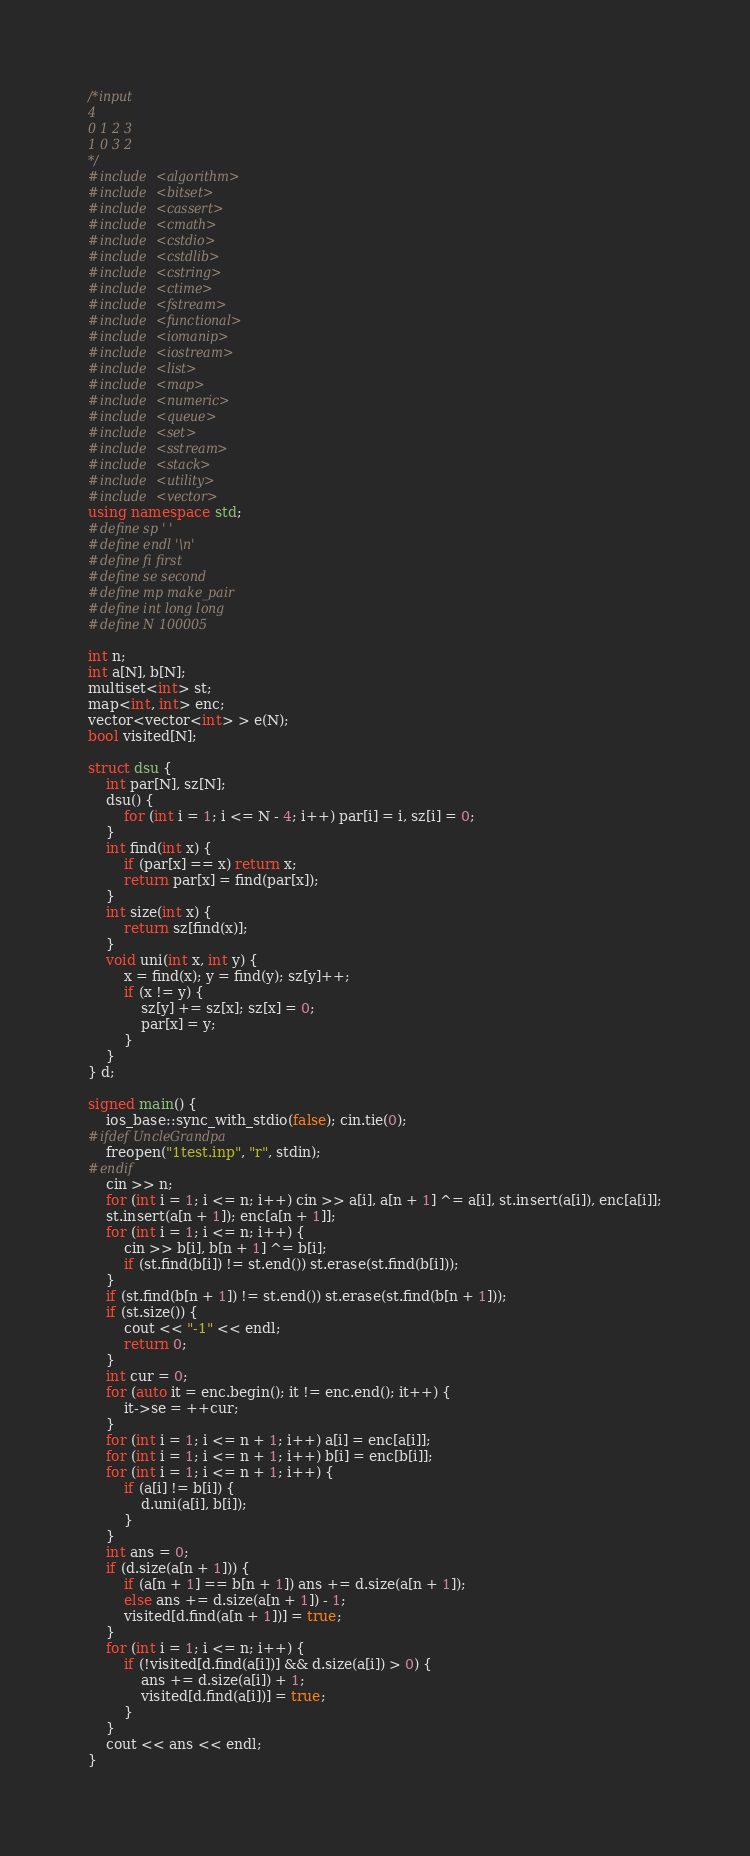<code> <loc_0><loc_0><loc_500><loc_500><_C++_>/*input
4
0 1 2 3
1 0 3 2
*/
#include <algorithm>
#include <bitset>
#include <cassert>
#include <cmath>
#include <cstdio>
#include <cstdlib>
#include <cstring>
#include <ctime>
#include <fstream>
#include <functional>
#include <iomanip>
#include <iostream>
#include <list>
#include <map>
#include <numeric>
#include <queue>
#include <set>
#include <sstream>
#include <stack>
#include <utility>
#include <vector>
using namespace std;
#define sp ' '
#define endl '\n'
#define fi first
#define se second
#define mp make_pair
#define int long long
#define N 100005

int n;
int a[N], b[N];
multiset<int> st;
map<int, int> enc;
vector<vector<int> > e(N);
bool visited[N];

struct dsu {
	int par[N], sz[N];
	dsu() {
		for (int i = 1; i <= N - 4; i++) par[i] = i, sz[i] = 0;
	}
	int find(int x) {
		if (par[x] == x) return x;
		return par[x] = find(par[x]);
	}
	int size(int x) {
		return sz[find(x)];
	}
	void uni(int x, int y) {
		x = find(x); y = find(y); sz[y]++;
		if (x != y) {
			sz[y] += sz[x]; sz[x] = 0;
			par[x] = y;
		}
	}
} d;

signed main() {
	ios_base::sync_with_stdio(false); cin.tie(0);
#ifdef UncleGrandpa
	freopen("1test.inp", "r", stdin);
#endif
	cin >> n;
	for (int i = 1; i <= n; i++) cin >> a[i], a[n + 1] ^= a[i], st.insert(a[i]), enc[a[i]];
	st.insert(a[n + 1]); enc[a[n + 1]];
	for (int i = 1; i <= n; i++) {
		cin >> b[i], b[n + 1] ^= b[i];
		if (st.find(b[i]) != st.end()) st.erase(st.find(b[i]));
	}
	if (st.find(b[n + 1]) != st.end()) st.erase(st.find(b[n + 1]));
	if (st.size()) {
		cout << "-1" << endl;
		return 0;
	}
	int cur = 0;
	for (auto it = enc.begin(); it != enc.end(); it++) {
		it->se = ++cur;
	}
	for (int i = 1; i <= n + 1; i++) a[i] = enc[a[i]];
	for (int i = 1; i <= n + 1; i++) b[i] = enc[b[i]];
	for (int i = 1; i <= n + 1; i++) {
		if (a[i] != b[i]) {
			d.uni(a[i], b[i]);
		}
	}
	int ans = 0;
	if (d.size(a[n + 1])) {
		if (a[n + 1] == b[n + 1]) ans += d.size(a[n + 1]);
		else ans += d.size(a[n + 1]) - 1;
		visited[d.find(a[n + 1])] = true;
	}
	for (int i = 1; i <= n; i++) {
		if (!visited[d.find(a[i])] && d.size(a[i]) > 0) {
			ans += d.size(a[i]) + 1;
			visited[d.find(a[i])] = true;
		}
	}
	cout << ans << endl;
}</code> 